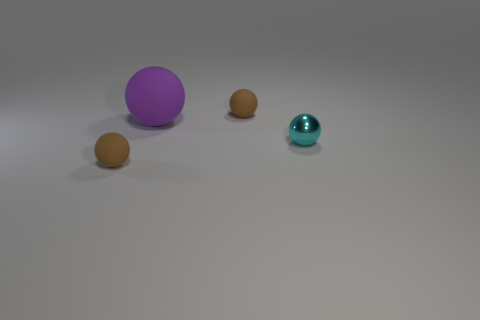Add 1 red rubber things. How many objects exist? 5 Add 2 tiny brown spheres. How many tiny brown spheres are left? 4 Add 4 tiny shiny cylinders. How many tiny shiny cylinders exist? 4 Subtract 0 gray blocks. How many objects are left? 4 Subtract all metallic spheres. Subtract all small red objects. How many objects are left? 3 